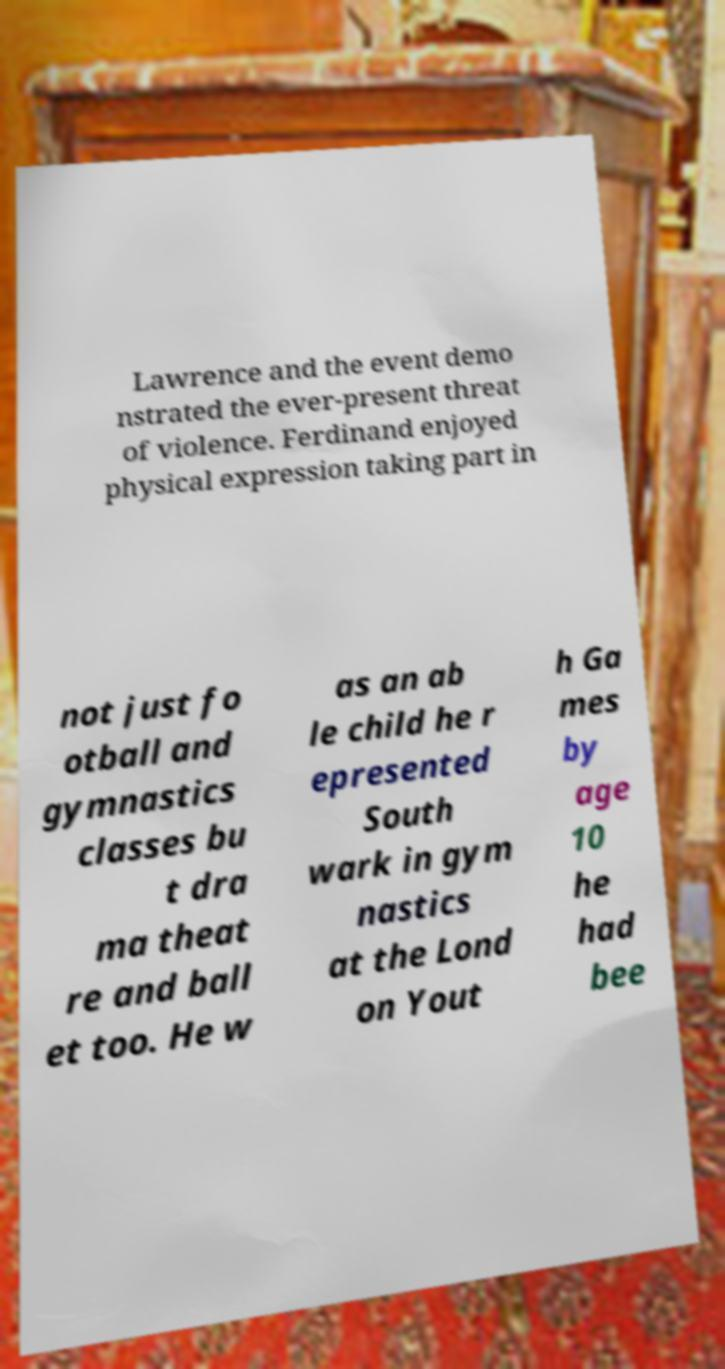For documentation purposes, I need the text within this image transcribed. Could you provide that? Lawrence and the event demo nstrated the ever-present threat of violence. Ferdinand enjoyed physical expression taking part in not just fo otball and gymnastics classes bu t dra ma theat re and ball et too. He w as an ab le child he r epresented South wark in gym nastics at the Lond on Yout h Ga mes by age 10 he had bee 